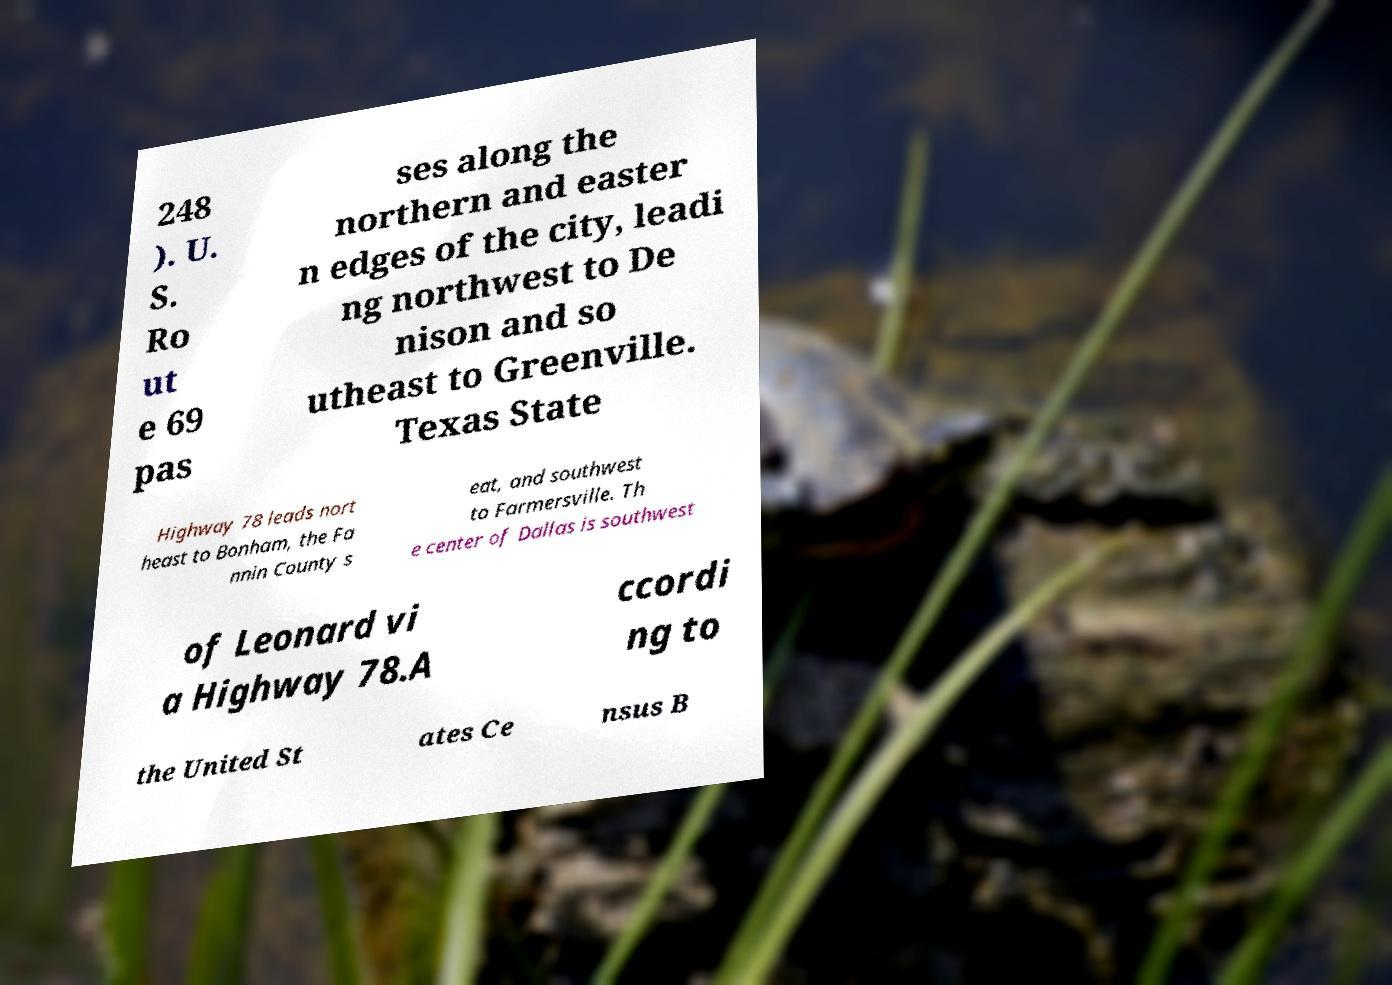I need the written content from this picture converted into text. Can you do that? 248 ). U. S. Ro ut e 69 pas ses along the northern and easter n edges of the city, leadi ng northwest to De nison and so utheast to Greenville. Texas State Highway 78 leads nort heast to Bonham, the Fa nnin County s eat, and southwest to Farmersville. Th e center of Dallas is southwest of Leonard vi a Highway 78.A ccordi ng to the United St ates Ce nsus B 